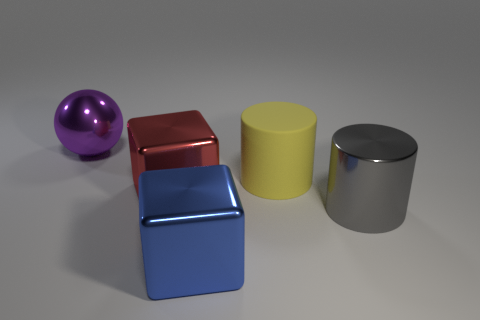What can be inferred about the setting of these objects? Given the uniform background and the quality of the shadows, it seems these objects are placed in an indoor setting with controlled lighting, perhaps for the purpose of a display or a photography studio setup. 